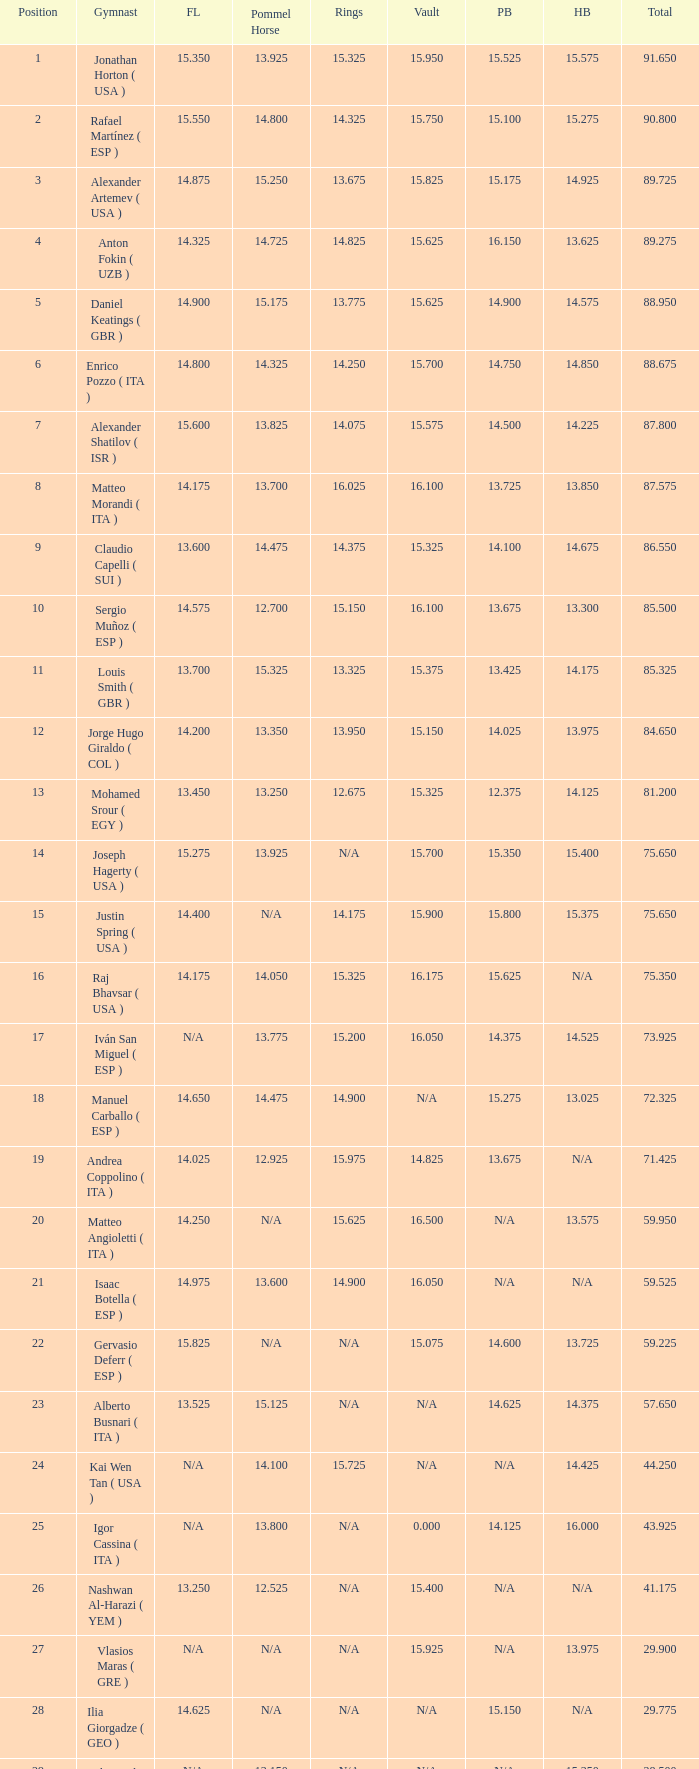If the parallel bars is 14.025, what is the total number of gymnasts? 1.0. 